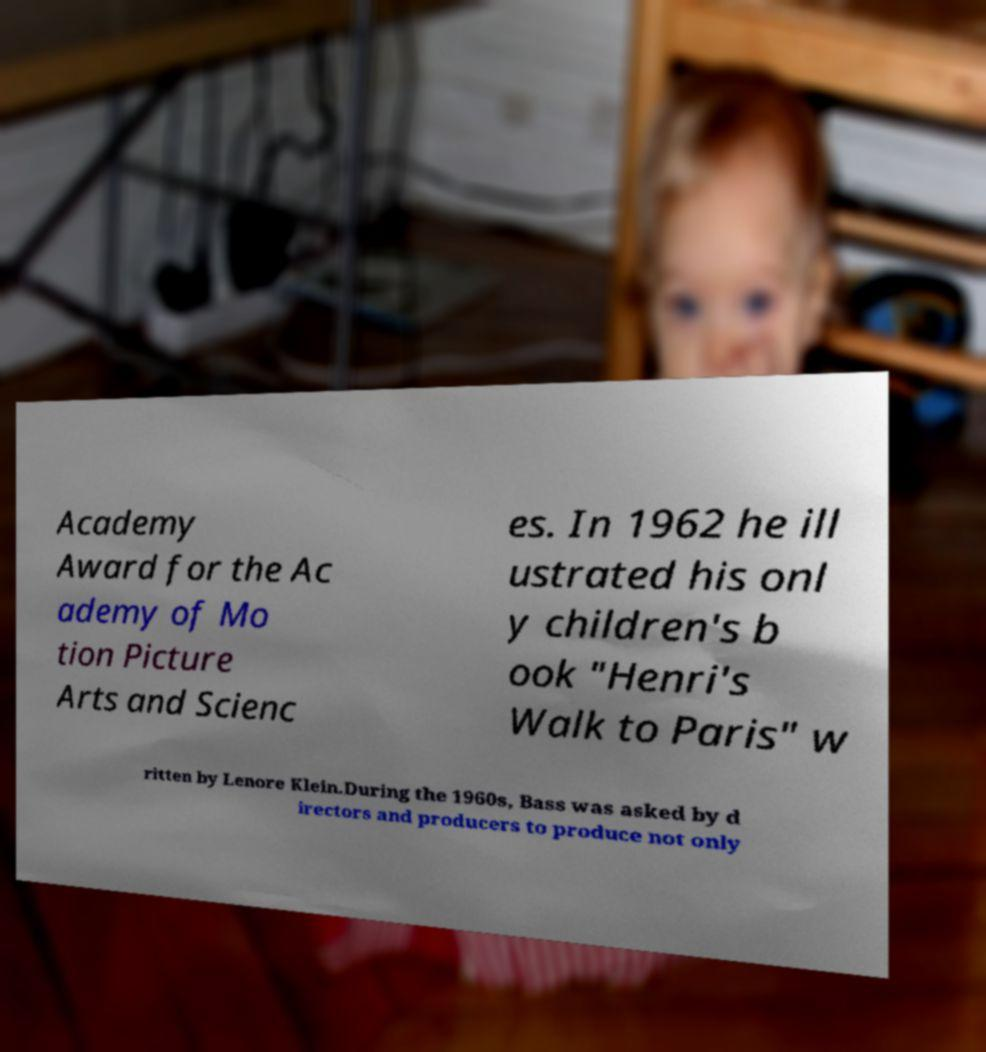Could you extract and type out the text from this image? Academy Award for the Ac ademy of Mo tion Picture Arts and Scienc es. In 1962 he ill ustrated his onl y children's b ook "Henri's Walk to Paris" w ritten by Lenore Klein.During the 1960s, Bass was asked by d irectors and producers to produce not only 